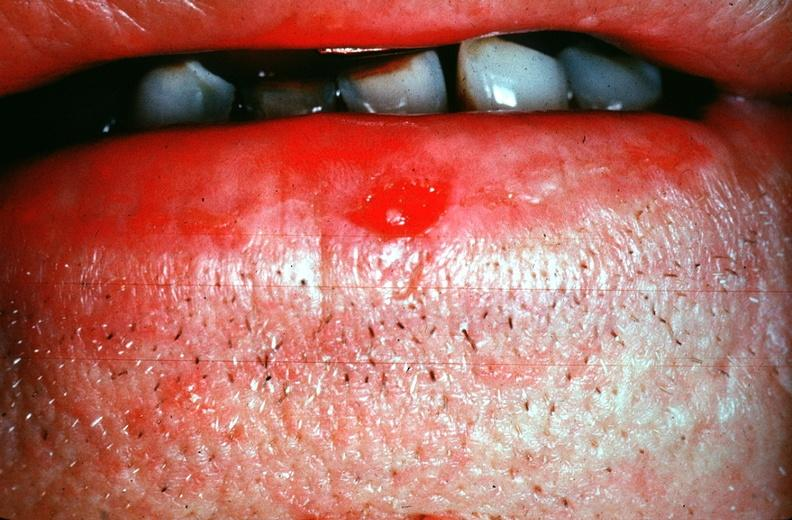where is this?
Answer the question using a single word or phrase. Skin 